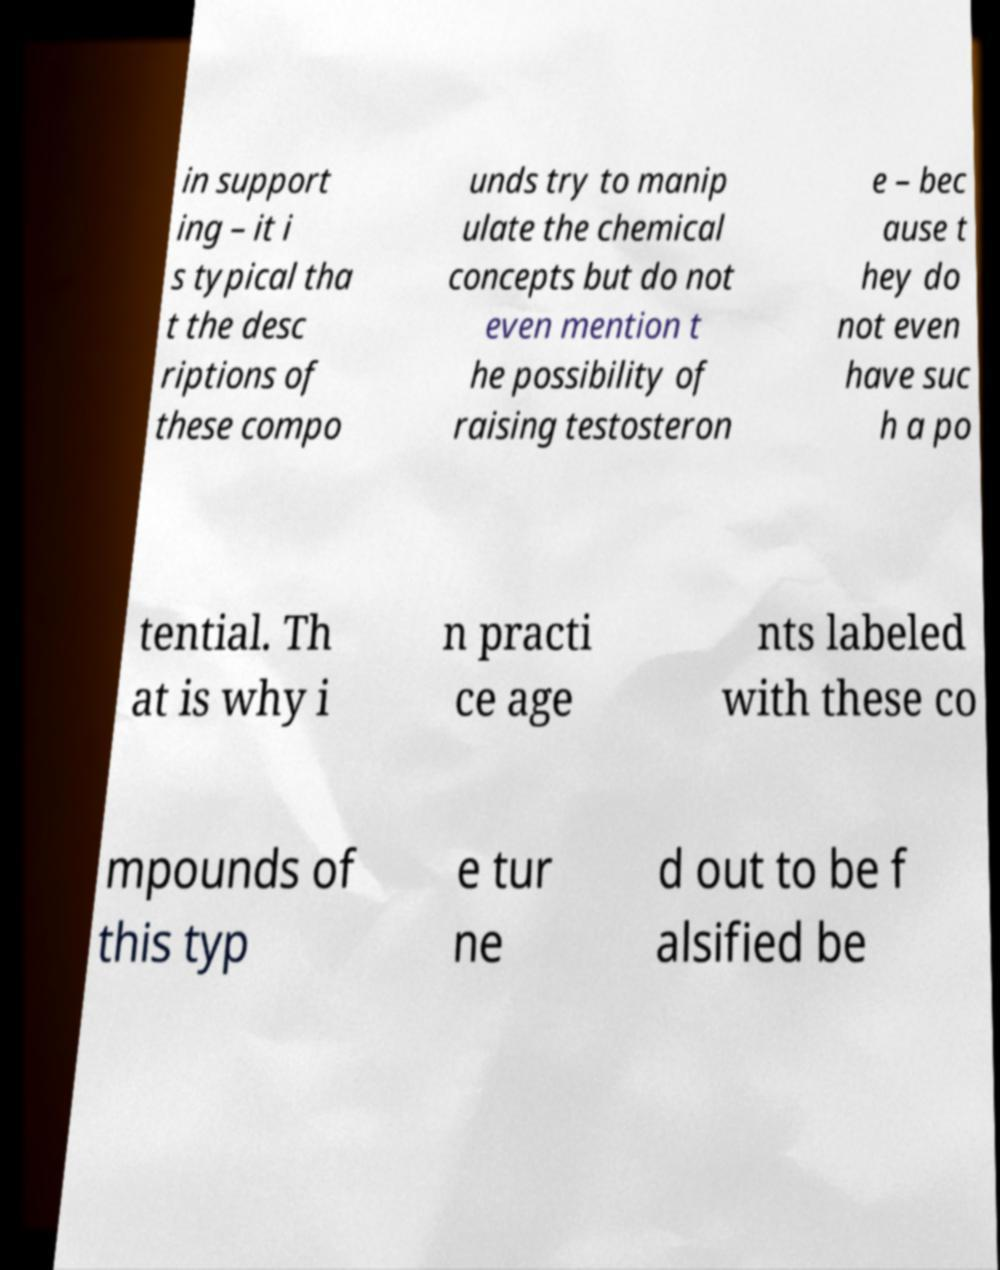There's text embedded in this image that I need extracted. Can you transcribe it verbatim? in support ing – it i s typical tha t the desc riptions of these compo unds try to manip ulate the chemical concepts but do not even mention t he possibility of raising testosteron e – bec ause t hey do not even have suc h a po tential. Th at is why i n practi ce age nts labeled with these co mpounds of this typ e tur ne d out to be f alsified be 